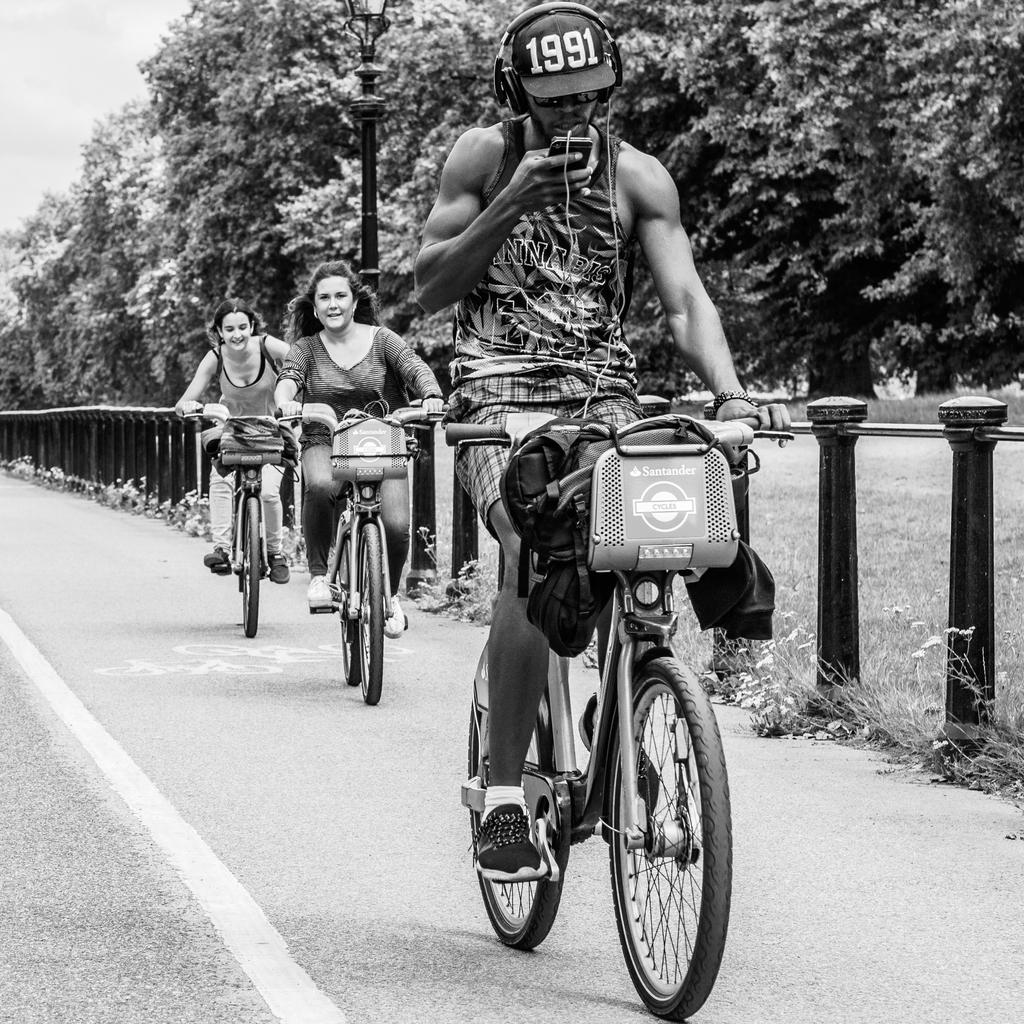What type of natural elements can be seen in the image? There are trees in the image. How many people are present in the image? There are three people in the image. What are the people doing in the image? The people are riding bicycles. What type of pathway is visible in the image? There is a road in the image. Can you tell me what type of lock is used by the beggar in the image? There is no beggar present in the image, and therefore no lock can be associated with them. 